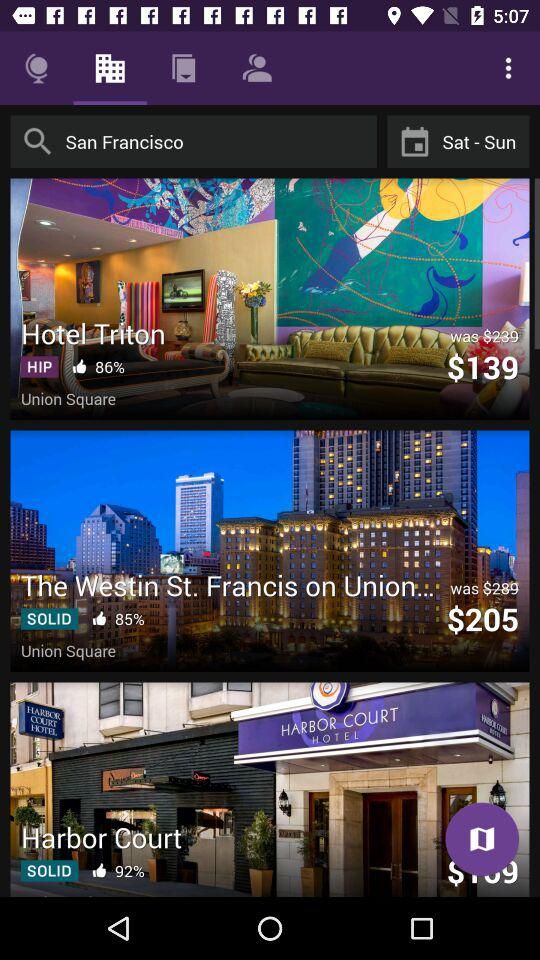What hotel is in hip? The hotel which is in the hip is Hotel Triton. 